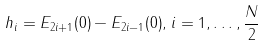Convert formula to latex. <formula><loc_0><loc_0><loc_500><loc_500>h _ { i } = E _ { 2 i + 1 } ( 0 ) - E _ { 2 i - 1 } ( 0 ) , \, i = 1 , \dots , \frac { N } { 2 }</formula> 